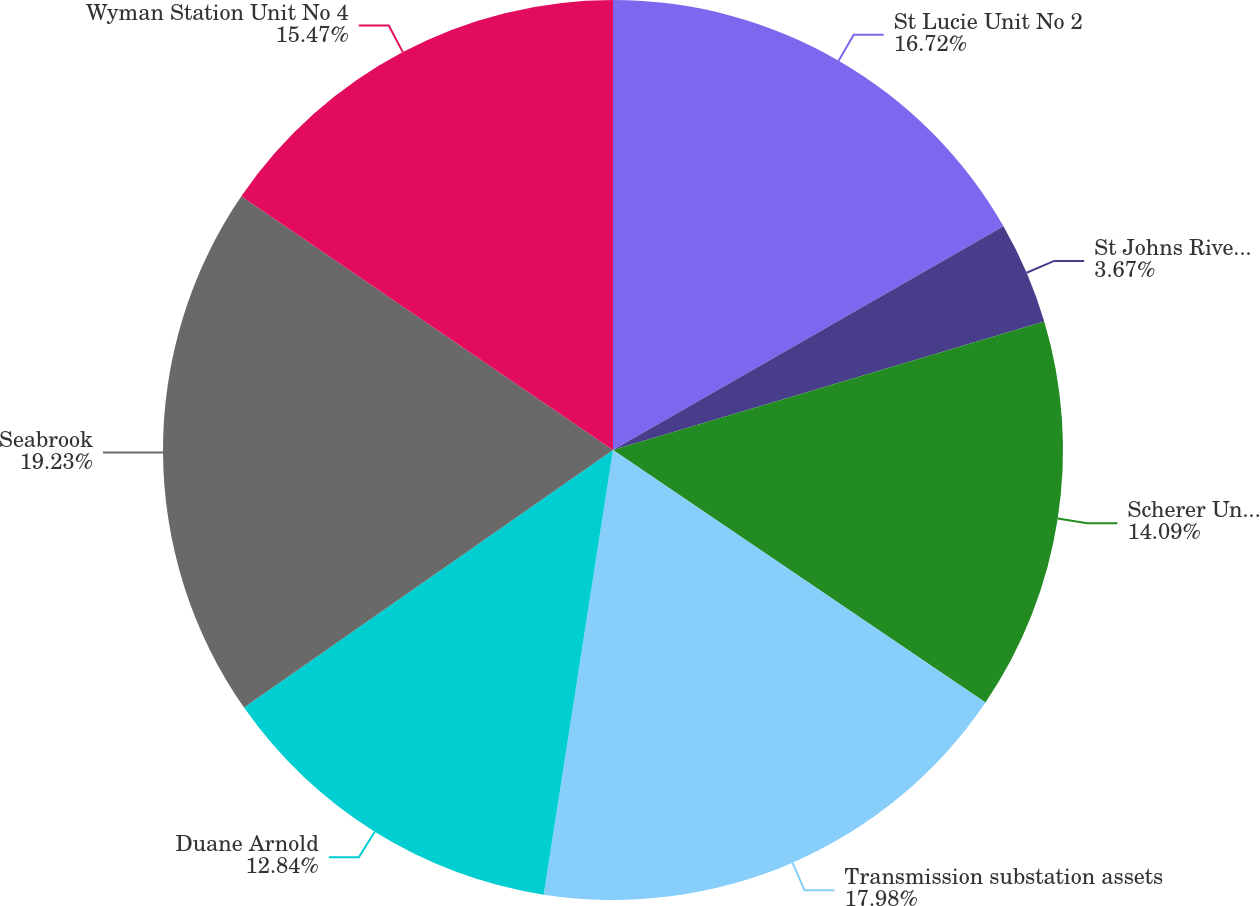Convert chart to OTSL. <chart><loc_0><loc_0><loc_500><loc_500><pie_chart><fcel>St Lucie Unit No 2<fcel>St Johns River Power Park<fcel>Scherer Unit No 4<fcel>Transmission substation assets<fcel>Duane Arnold<fcel>Seabrook<fcel>Wyman Station Unit No 4<nl><fcel>16.72%<fcel>3.67%<fcel>14.09%<fcel>17.98%<fcel>12.84%<fcel>19.23%<fcel>15.47%<nl></chart> 